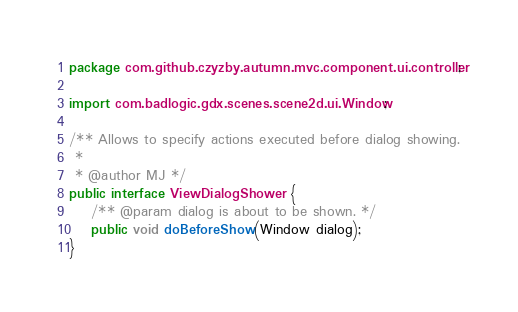Convert code to text. <code><loc_0><loc_0><loc_500><loc_500><_Java_>package com.github.czyzby.autumn.mvc.component.ui.controller;

import com.badlogic.gdx.scenes.scene2d.ui.Window;

/** Allows to specify actions executed before dialog showing.
 *
 * @author MJ */
public interface ViewDialogShower {
    /** @param dialog is about to be shown. */
    public void doBeforeShow(Window dialog);
}
</code> 